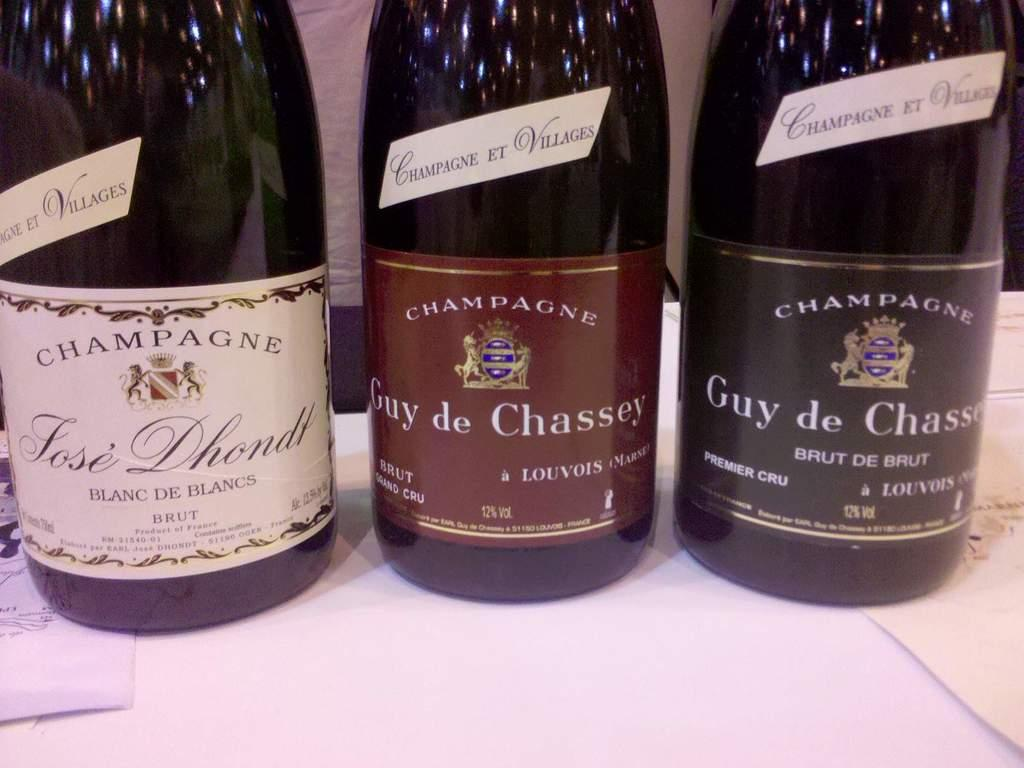<image>
Relay a brief, clear account of the picture shown. 3 different bottles of Champagne sitting on a table. 